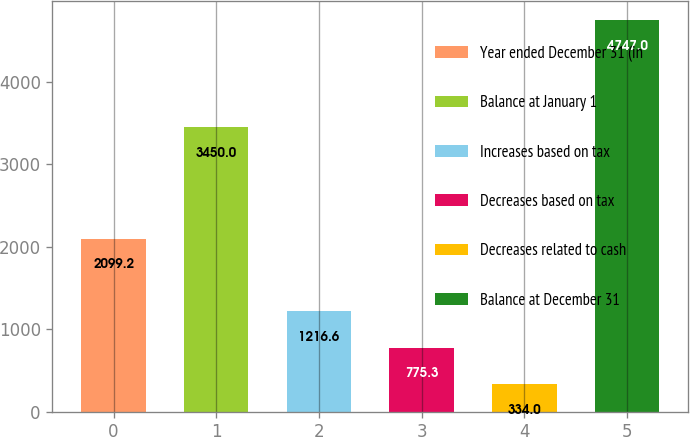Convert chart to OTSL. <chart><loc_0><loc_0><loc_500><loc_500><bar_chart><fcel>Year ended December 31 (in<fcel>Balance at January 1<fcel>Increases based on tax<fcel>Decreases based on tax<fcel>Decreases related to cash<fcel>Balance at December 31<nl><fcel>2099.2<fcel>3450<fcel>1216.6<fcel>775.3<fcel>334<fcel>4747<nl></chart> 